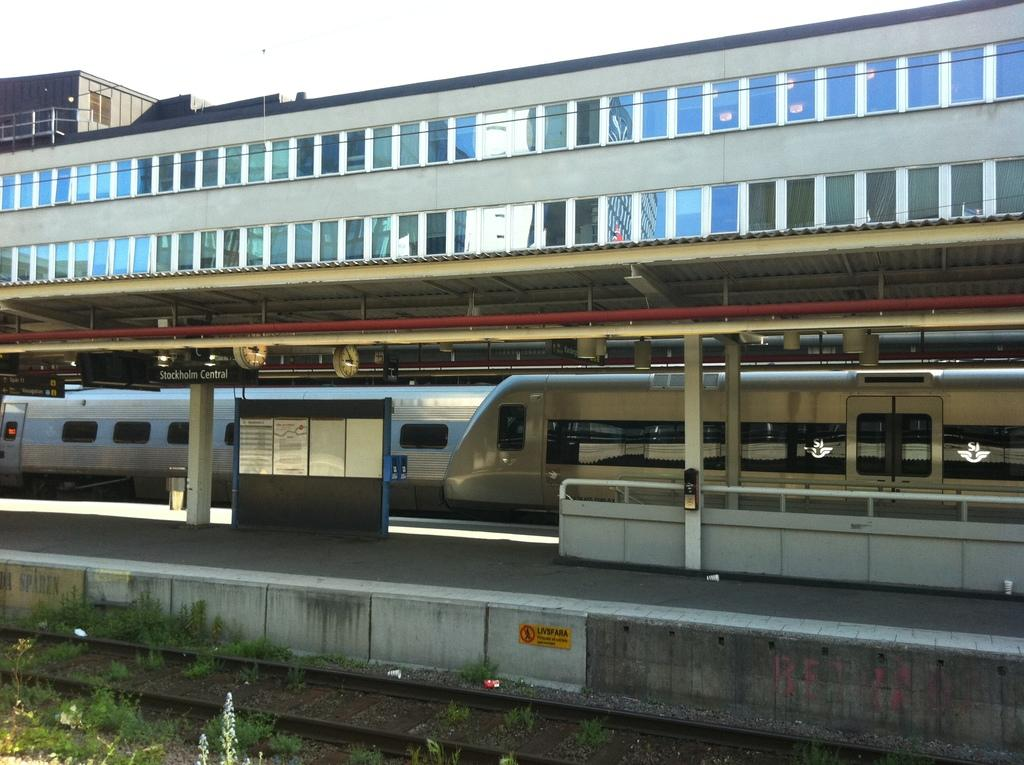What is the main structure in the center of the image? There is a building in the center of the image. What is located near the building? There is a platform and railway track in the image. What type of vehicles can be seen in the image? There are trains in the image. What architectural feature is present in the image? There are pillars in the image. What type of vegetation is visible in the image? There is grass in the image. Are there any other objects or features in the image? Yes, there are a few other objects in the image. What type of feast is being held on the platform in the image? There is no feast present in the image; it features a building, platform, railway track, trains, pillars, grass, and a few other objects. What political act is being performed by the trains in the image? There is no political act being performed by the trains in the image; they are simply stationary or moving along the railway track. 